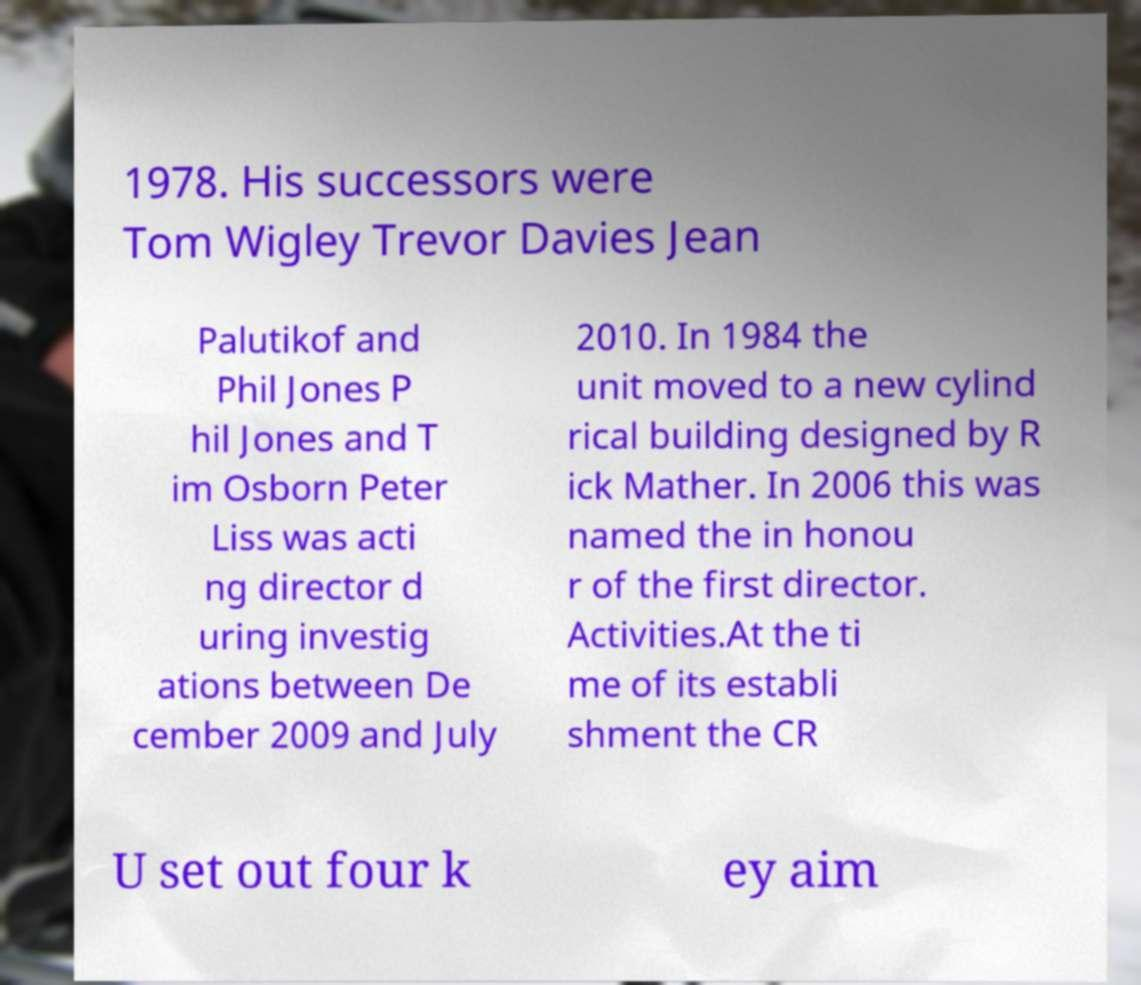Please identify and transcribe the text found in this image. 1978. His successors were Tom Wigley Trevor Davies Jean Palutikof and Phil Jones P hil Jones and T im Osborn Peter Liss was acti ng director d uring investig ations between De cember 2009 and July 2010. In 1984 the unit moved to a new cylind rical building designed by R ick Mather. In 2006 this was named the in honou r of the first director. Activities.At the ti me of its establi shment the CR U set out four k ey aim 